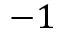Convert formula to latex. <formula><loc_0><loc_0><loc_500><loc_500>- 1</formula> 